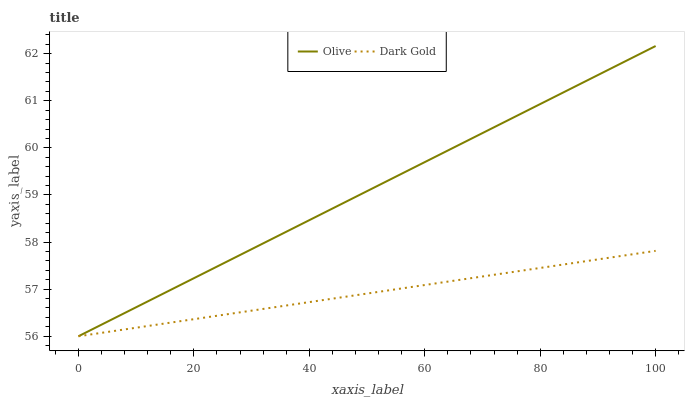Does Dark Gold have the minimum area under the curve?
Answer yes or no. Yes. Does Olive have the maximum area under the curve?
Answer yes or no. Yes. Does Dark Gold have the maximum area under the curve?
Answer yes or no. No. Is Olive the smoothest?
Answer yes or no. Yes. Is Dark Gold the roughest?
Answer yes or no. Yes. Is Dark Gold the smoothest?
Answer yes or no. No. Does Olive have the lowest value?
Answer yes or no. Yes. Does Olive have the highest value?
Answer yes or no. Yes. Does Dark Gold have the highest value?
Answer yes or no. No. Does Dark Gold intersect Olive?
Answer yes or no. Yes. Is Dark Gold less than Olive?
Answer yes or no. No. Is Dark Gold greater than Olive?
Answer yes or no. No. 